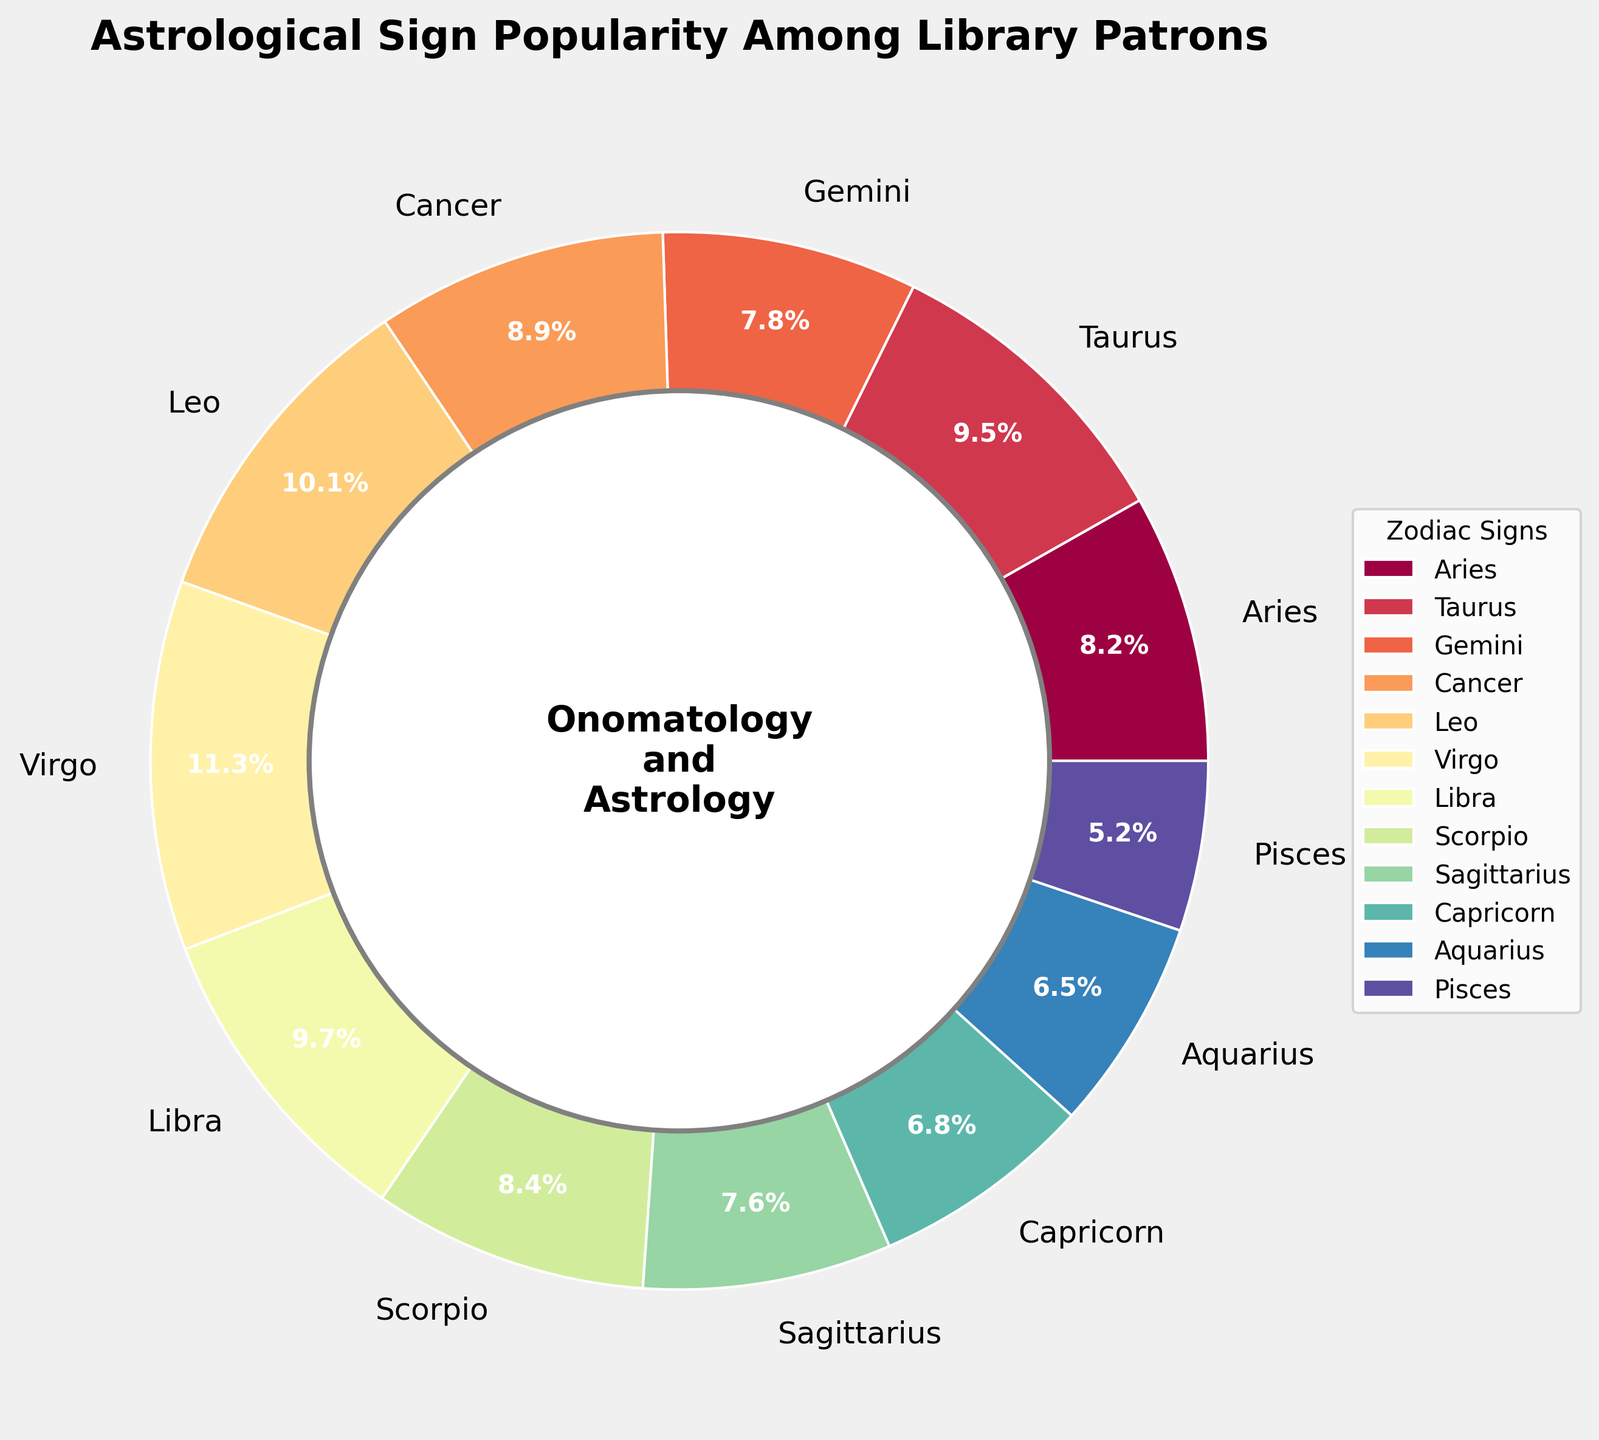Which astrological sign is the most popular among library patrons? By looking at the pie chart, the sign with the largest slice is Virgo.
Answer: Virgo Which astrological sign is the least popular among library patrons? By examining the pie chart, the sign with the smallest slice is Pisces.
Answer: Pisces What is the combined percentage of Leo and Virgo? From the chart, Leo has a percentage of 10.1% and Virgo has 11.3%. Summing these two values gives 10.1% + 11.3% = 21.4%.
Answer: 21.4% How much more popular is Libra compared to Pisces? According to the chart, Libra has a percentage of 9.7% and Pisces has 5.2%. The difference between them is 9.7% - 5.2% = 4.5%.
Answer: 4.5% Which signs have a percentage higher than 10%? The pie chart shows that Leo and Virgo have percentages greater than 10%.
Answer: Leo and Virgo What is the average percentage of Gemini, Cancer, Leo, and Virgo? The percentages are: Gemini (7.8%), Cancer (8.9%), Leo (10.1%), and Virgo (11.3%). Calculating the average: (7.8 + 8.9 + 10.1 + 11.3) / 4 = 9.525%.
Answer: 9.525% Are there any signs with a popularity percentage below 7%? If so, which ones? The chart indicates that Capricorn and Aquarius both have percentages below 7% with 6.8% and 6.5%, respectively.
Answer: Capricorn and Aquarius Which sign is more popular, Scorpio or Aries, and by how much? Scorpio has a percentage of 8.4% while Aries has 8.2%. The difference is 8.4% - 8.2% = 0.2%.
Answer: Scorpio by 0.2% If you combine the percentages of Sagittarius, Aquarius, and Pisces, what do they account for together? From the chart, Sagittarius is at 7.6%, Aquarius at 6.5%, and Pisces at 5.2%. Summing these values gives 7.6% + 6.5% + 5.2% = 19.3%.
Answer: 19.3% 